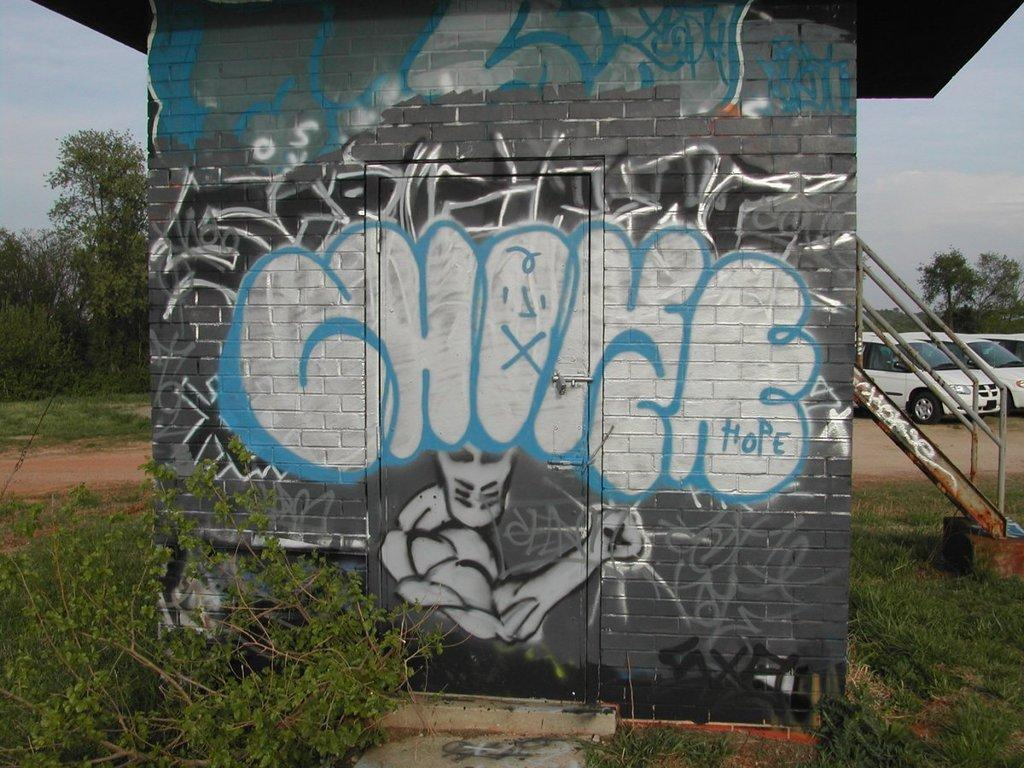What type of natural environment is visible in the image? There is grass in the image, which suggests a natural environment. What can be seen on the wall in the image? There is a depiction on the wall in the image. What type of objects can be seen in the background of the image? Vehicles and trees are visible in the background of the image. What is visible in the sky in the background of the image? Clouds are present in the sky in the background of the image. What type of account is being discussed in the image? There is no mention of an account in the image; it features grass, a depiction on the wall, vehicles, trees, and clouds. 